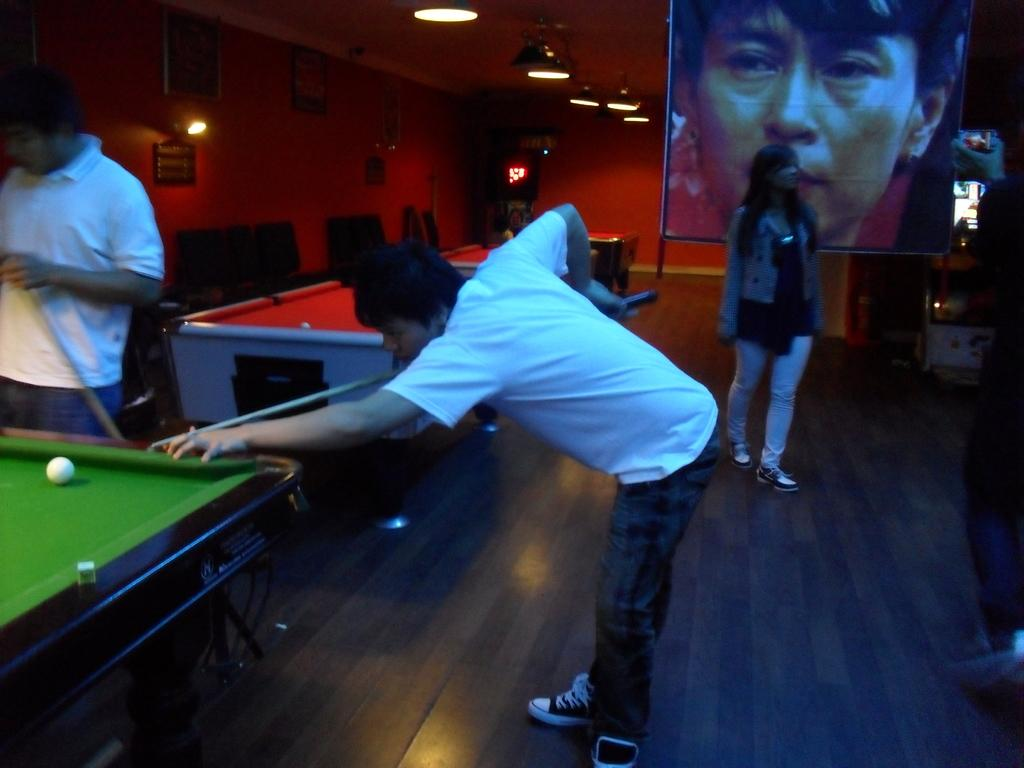How many people are in the image? There are 2 persons standing in the image. What activity are the persons engaged in? The persons are playing a snooker game. What is the main object used for playing the game? There is a snookers board in the image. What can be seen in the background of the image? There is a screen and another person in the background of the image. What type of furniture is present in the background? There are chairs in the background of the image. Can you describe the lighting in the image? There is light visible in the image. What type of rifle is being used by the person in the hospital in the image? There is no rifle or hospital present in the image. What is the person's interest in the game, and how does it affect their performance? The image does not provide information about the person's interest in the game or how it affects their performance. 